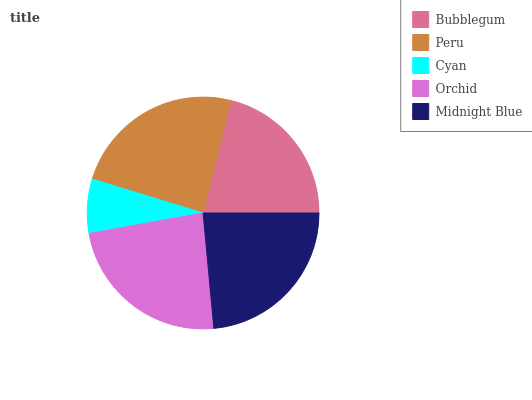Is Cyan the minimum?
Answer yes or no. Yes. Is Peru the maximum?
Answer yes or no. Yes. Is Peru the minimum?
Answer yes or no. No. Is Cyan the maximum?
Answer yes or no. No. Is Peru greater than Cyan?
Answer yes or no. Yes. Is Cyan less than Peru?
Answer yes or no. Yes. Is Cyan greater than Peru?
Answer yes or no. No. Is Peru less than Cyan?
Answer yes or no. No. Is Midnight Blue the high median?
Answer yes or no. Yes. Is Midnight Blue the low median?
Answer yes or no. Yes. Is Peru the high median?
Answer yes or no. No. Is Peru the low median?
Answer yes or no. No. 